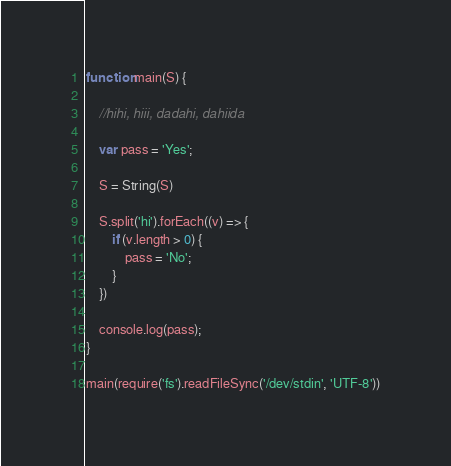<code> <loc_0><loc_0><loc_500><loc_500><_JavaScript_>function main(S) {
 
    //hihi, hiii, dadahi, dahiida
 
    var pass = 'Yes';
  
  	S = String(S)
 
    S.split('hi').forEach((v) => {
        if (v.length > 0) {
            pass = 'No';
        }
    })
 
    console.log(pass);
}

main(require('fs').readFileSync('/dev/stdin', 'UTF-8'))</code> 